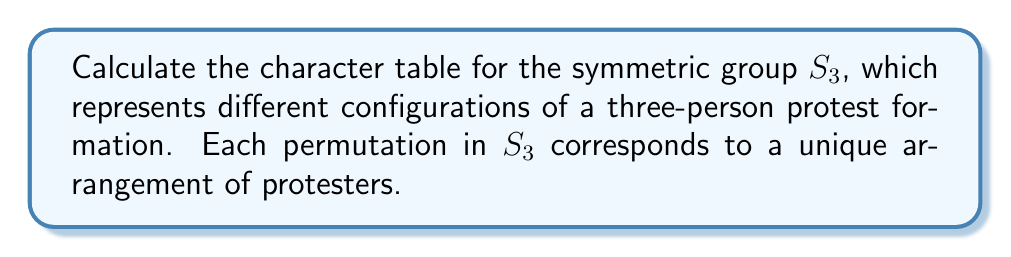Can you solve this math problem? To calculate the character table for $S_3$, we'll follow these steps:

1) First, identify the conjugacy classes of $S_3$:
   - $C_1 = \{e\}$ (identity)
   - $C_2 = \{(12), (13), (23)\}$ (transpositions)
   - $C_3 = \{(123), (132)\}$ (3-cycles)

2) The number of irreducible representations is equal to the number of conjugacy classes, so we have 3 irreducible representations.

3) The dimensions of these representations must satisfy:
   $1^2 + 1^2 + 2^2 = 6$ (order of $S_3$)
   So, we have two 1-dimensional representations and one 2-dimensional representation.

4) The trivial representation $\chi_1$ always has character 1 for all elements.

5) The sign representation $\chi_2$ has character 1 for even permutations and -1 for odd permutations.

6) For the 2-dimensional representation $\chi_3$, we can use the fact that the sum of squares of the dimensions equals the order of the group:
   $\chi_3(e) = 2$
   $\chi_3((12)) = 0$ (can be derived from orthogonality relations)
   $\chi_3((123)) = -1$ (can be derived from the fact that the sum of all characters in a column must be zero)

7) Construct the character table:

   $$
   \begin{array}{c|ccc}
    S_3 & C_1 & C_2 & C_3 \\
    \hline
    \chi_1 & 1 & 1 & 1 \\
    \chi_2 & 1 & -1 & 1 \\
    \chi_3 & 2 & 0 & -1
   \end{array}
   $$

This character table represents how the different protest configurations transform under the symmetric group $S_3$.
Answer: $$
\begin{array}{c|ccc}
S_3 & C_1 & C_2 & C_3 \\
\hline
\chi_1 & 1 & 1 & 1 \\
\chi_2 & 1 & -1 & 1 \\
\chi_3 & 2 & 0 & -1
\end{array}
$$ 